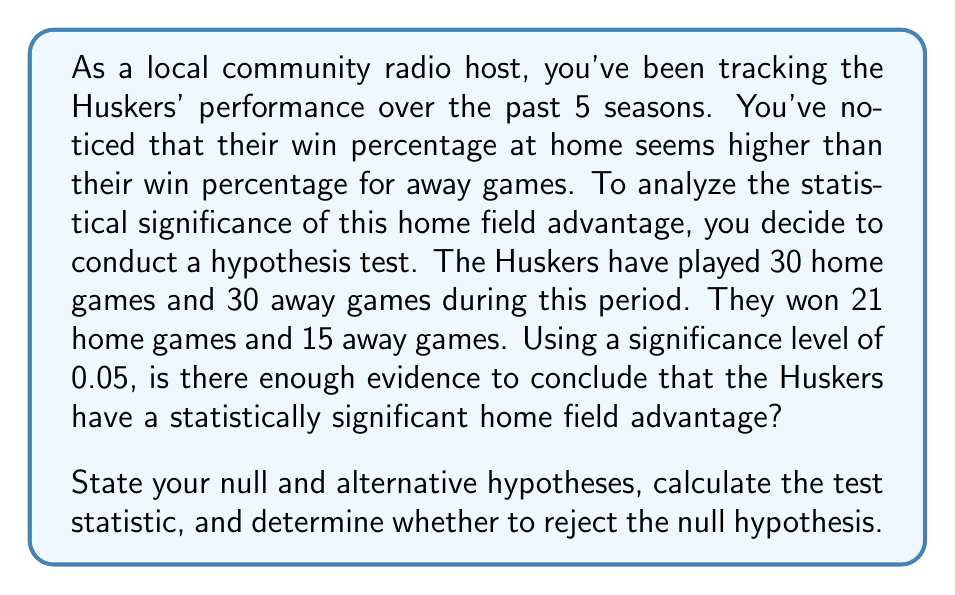What is the answer to this math problem? Let's approach this step-by-step:

1) First, we need to set up our hypotheses:
   $H_0: p_{home} = p_{away}$ (Null hypothesis: There's no difference in win proportions)
   $H_a: p_{home} > p_{away}$ (Alternative hypothesis: Home win proportion is greater)

2) We'll use a two-proportion z-test for this analysis.

3) Calculate the pooled proportion:
   $$\hat{p} = \frac{X_1 + X_2}{n_1 + n_2} = \frac{21 + 15}{30 + 30} = \frac{36}{60} = 0.6$$

4) Calculate the standard error:
   $$SE = \sqrt{\hat{p}(1-\hat{p})(\frac{1}{n_1} + \frac{1}{n_2})}$$
   $$SE = \sqrt{0.6(1-0.6)(\frac{1}{30} + \frac{1}{30})} = \sqrt{0.24 \cdot \frac{1}{15}} = 0.1265$$

5) Calculate the z-statistic:
   $$z = \frac{(\hat{p}_1 - \hat{p}_2) - 0}{SE} = \frac{(\frac{21}{30} - \frac{15}{30}) - 0}{0.1265} = \frac{0.2}{0.1265} = 1.58$$

6) Find the critical value:
   For a one-tailed test at α = 0.05, the critical z-value is 1.645.

7) Decision rule:
   Reject $H_0$ if z > 1.645

8) Conclusion:
   Since 1.58 < 1.645, we fail to reject the null hypothesis at the 0.05 significance level.
Answer: Fail to reject the null hypothesis. There is not enough evidence to conclude that the Huskers have a statistically significant home field advantage at the 0.05 significance level. 